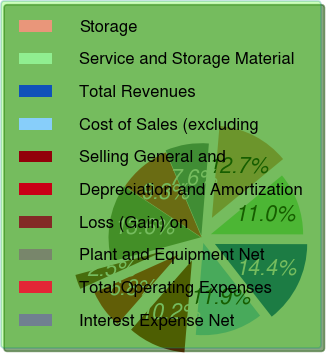<chart> <loc_0><loc_0><loc_500><loc_500><pie_chart><fcel>Storage<fcel>Service and Storage Material<fcel>Total Revenues<fcel>Cost of Sales (excluding<fcel>Selling General and<fcel>Depreciation and Amortization<fcel>Loss (Gain) on<fcel>Plant and Equipment Net<fcel>Total Operating Expenses<fcel>Interest Expense Net<nl><fcel>12.71%<fcel>11.02%<fcel>14.41%<fcel>11.86%<fcel>10.17%<fcel>6.78%<fcel>2.54%<fcel>13.56%<fcel>9.32%<fcel>7.63%<nl></chart> 